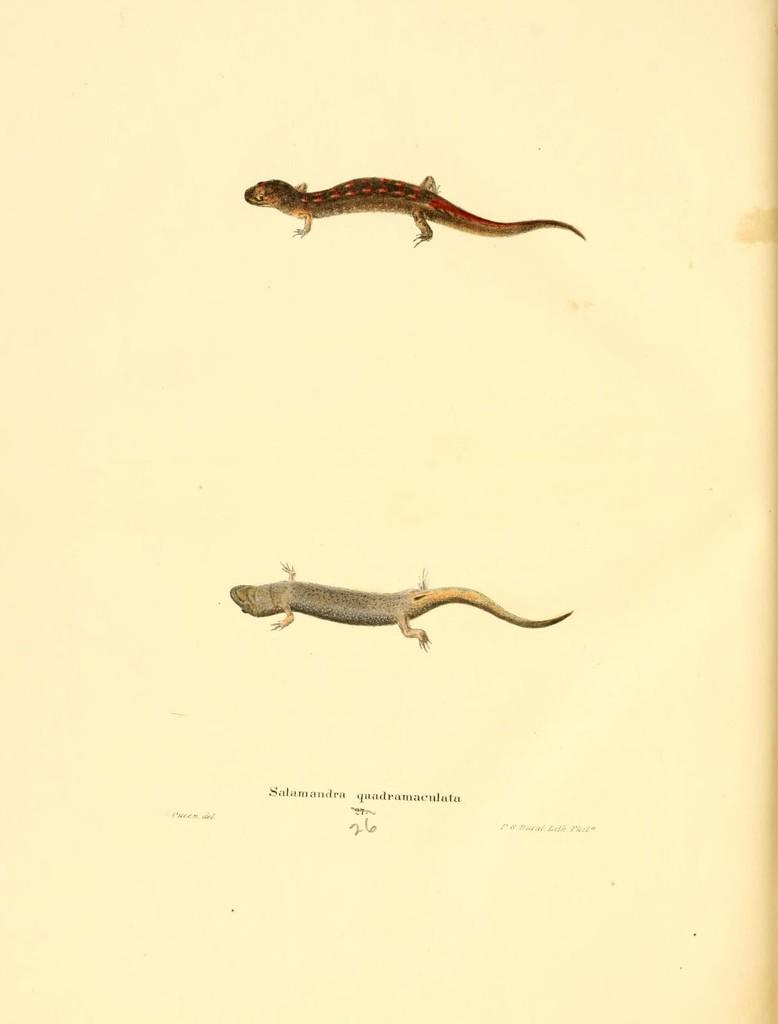What type of animals are in the image? There are two lizards in the image. Where are the lizards located? The lizards are on a platform. What is written on the platform at the bottom? There is text written on the platform at the bottom. What type of ornament is hanging from the lizard's mouth in the image? There is no ornament present in the image, and the lizards' mouths are not depicted as holding anything. 